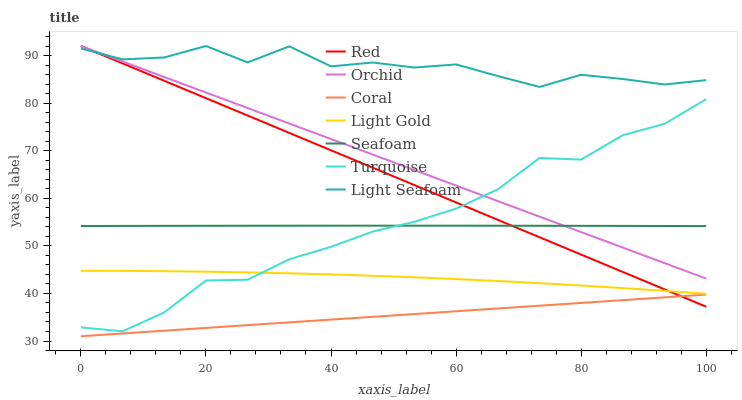Does Coral have the minimum area under the curve?
Answer yes or no. Yes. Does Light Seafoam have the maximum area under the curve?
Answer yes or no. Yes. Does Seafoam have the minimum area under the curve?
Answer yes or no. No. Does Seafoam have the maximum area under the curve?
Answer yes or no. No. Is Coral the smoothest?
Answer yes or no. Yes. Is Light Seafoam the roughest?
Answer yes or no. Yes. Is Seafoam the smoothest?
Answer yes or no. No. Is Seafoam the roughest?
Answer yes or no. No. Does Coral have the lowest value?
Answer yes or no. Yes. Does Seafoam have the lowest value?
Answer yes or no. No. Does Orchid have the highest value?
Answer yes or no. Yes. Does Seafoam have the highest value?
Answer yes or no. No. Is Coral less than Orchid?
Answer yes or no. Yes. Is Light Gold greater than Coral?
Answer yes or no. Yes. Does Turquoise intersect Seafoam?
Answer yes or no. Yes. Is Turquoise less than Seafoam?
Answer yes or no. No. Is Turquoise greater than Seafoam?
Answer yes or no. No. Does Coral intersect Orchid?
Answer yes or no. No. 